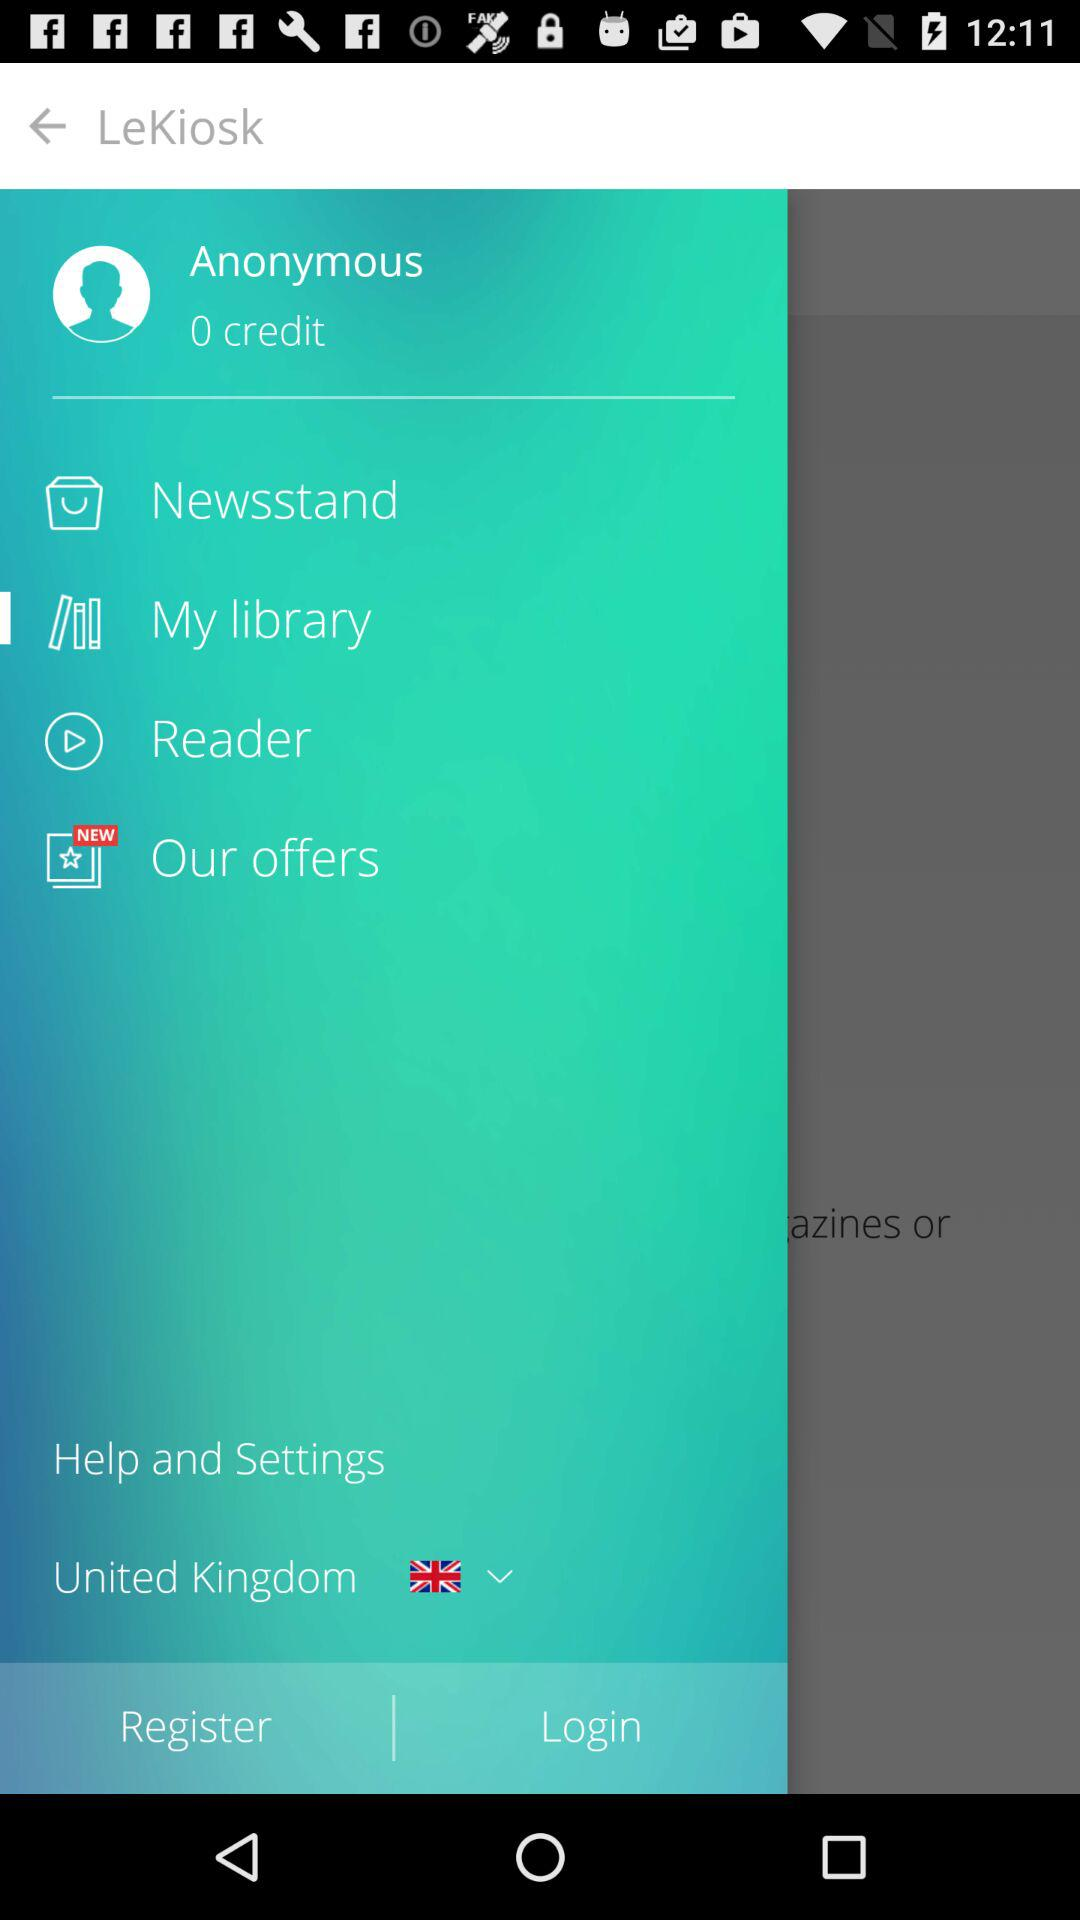How much credit is earned? There is 0 credit earned. 